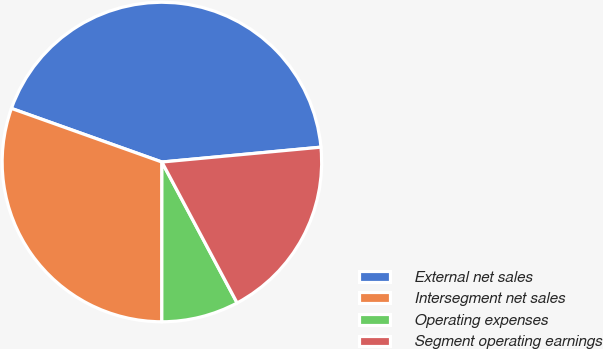Convert chart to OTSL. <chart><loc_0><loc_0><loc_500><loc_500><pie_chart><fcel>External net sales<fcel>Intersegment net sales<fcel>Operating expenses<fcel>Segment operating earnings<nl><fcel>43.07%<fcel>30.44%<fcel>7.81%<fcel>18.68%<nl></chart> 